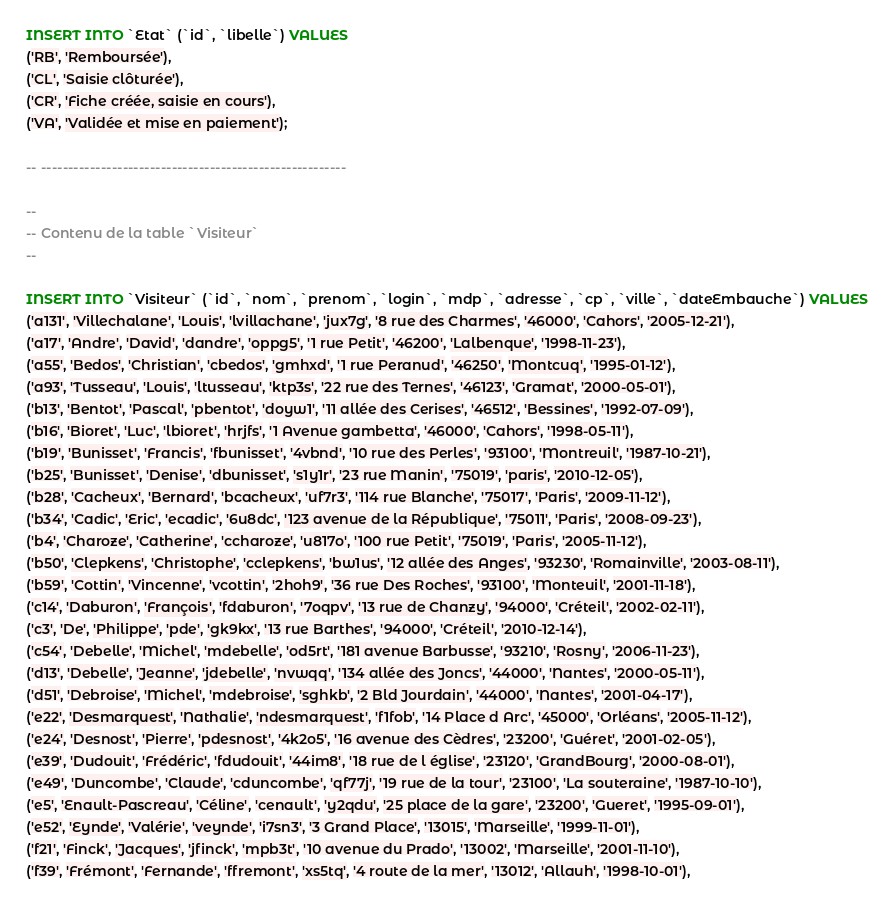Convert code to text. <code><loc_0><loc_0><loc_500><loc_500><_SQL_>
INSERT INTO `Etat` (`id`, `libelle`) VALUES
('RB', 'Remboursée'),
('CL', 'Saisie clôturée'),
('CR', 'Fiche créée, saisie en cours'),
('VA', 'Validée et mise en paiement');

-- --------------------------------------------------------

--
-- Contenu de la table `Visiteur`
--

INSERT INTO `Visiteur` (`id`, `nom`, `prenom`, `login`, `mdp`, `adresse`, `cp`, `ville`, `dateEmbauche`) VALUES
('a131', 'Villechalane', 'Louis', 'lvillachane', 'jux7g', '8 rue des Charmes', '46000', 'Cahors', '2005-12-21'),
('a17', 'Andre', 'David', 'dandre', 'oppg5', '1 rue Petit', '46200', 'Lalbenque', '1998-11-23'),
('a55', 'Bedos', 'Christian', 'cbedos', 'gmhxd', '1 rue Peranud', '46250', 'Montcuq', '1995-01-12'),
('a93', 'Tusseau', 'Louis', 'ltusseau', 'ktp3s', '22 rue des Ternes', '46123', 'Gramat', '2000-05-01'),
('b13', 'Bentot', 'Pascal', 'pbentot', 'doyw1', '11 allée des Cerises', '46512', 'Bessines', '1992-07-09'),
('b16', 'Bioret', 'Luc', 'lbioret', 'hrjfs', '1 Avenue gambetta', '46000', 'Cahors', '1998-05-11'),
('b19', 'Bunisset', 'Francis', 'fbunisset', '4vbnd', '10 rue des Perles', '93100', 'Montreuil', '1987-10-21'),
('b25', 'Bunisset', 'Denise', 'dbunisset', 's1y1r', '23 rue Manin', '75019', 'paris', '2010-12-05'),
('b28', 'Cacheux', 'Bernard', 'bcacheux', 'uf7r3', '114 rue Blanche', '75017', 'Paris', '2009-11-12'),
('b34', 'Cadic', 'Eric', 'ecadic', '6u8dc', '123 avenue de la République', '75011', 'Paris', '2008-09-23'),
('b4', 'Charoze', 'Catherine', 'ccharoze', 'u817o', '100 rue Petit', '75019', 'Paris', '2005-11-12'),
('b50', 'Clepkens', 'Christophe', 'cclepkens', 'bw1us', '12 allée des Anges', '93230', 'Romainville', '2003-08-11'),
('b59', 'Cottin', 'Vincenne', 'vcottin', '2hoh9', '36 rue Des Roches', '93100', 'Monteuil', '2001-11-18'),
('c14', 'Daburon', 'François', 'fdaburon', '7oqpv', '13 rue de Chanzy', '94000', 'Créteil', '2002-02-11'),
('c3', 'De', 'Philippe', 'pde', 'gk9kx', '13 rue Barthes', '94000', 'Créteil', '2010-12-14'),
('c54', 'Debelle', 'Michel', 'mdebelle', 'od5rt', '181 avenue Barbusse', '93210', 'Rosny', '2006-11-23'),
('d13', 'Debelle', 'Jeanne', 'jdebelle', 'nvwqq', '134 allée des Joncs', '44000', 'Nantes', '2000-05-11'),
('d51', 'Debroise', 'Michel', 'mdebroise', 'sghkb', '2 Bld Jourdain', '44000', 'Nantes', '2001-04-17'),
('e22', 'Desmarquest', 'Nathalie', 'ndesmarquest', 'f1fob', '14 Place d Arc', '45000', 'Orléans', '2005-11-12'),
('e24', 'Desnost', 'Pierre', 'pdesnost', '4k2o5', '16 avenue des Cèdres', '23200', 'Guéret', '2001-02-05'),
('e39', 'Dudouit', 'Frédéric', 'fdudouit', '44im8', '18 rue de l église', '23120', 'GrandBourg', '2000-08-01'),
('e49', 'Duncombe', 'Claude', 'cduncombe', 'qf77j', '19 rue de la tour', '23100', 'La souteraine', '1987-10-10'),
('e5', 'Enault-Pascreau', 'Céline', 'cenault', 'y2qdu', '25 place de la gare', '23200', 'Gueret', '1995-09-01'),
('e52', 'Eynde', 'Valérie', 'veynde', 'i7sn3', '3 Grand Place', '13015', 'Marseille', '1999-11-01'),
('f21', 'Finck', 'Jacques', 'jfinck', 'mpb3t', '10 avenue du Prado', '13002', 'Marseille', '2001-11-10'),
('f39', 'Frémont', 'Fernande', 'ffremont', 'xs5tq', '4 route de la mer', '13012', 'Allauh', '1998-10-01'),</code> 